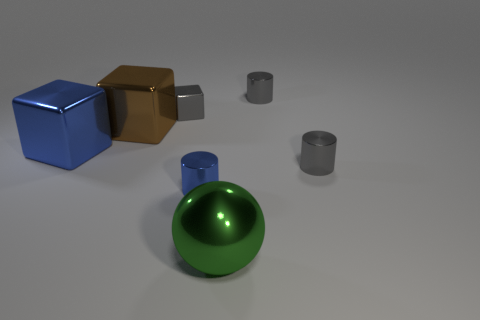Add 1 large blue shiny blocks. How many objects exist? 8 Subtract all blocks. How many objects are left? 4 Subtract 1 brown blocks. How many objects are left? 6 Subtract all blue rubber cylinders. Subtract all big blue things. How many objects are left? 6 Add 5 big blue metal cubes. How many big blue metal cubes are left? 6 Add 4 big cubes. How many big cubes exist? 6 